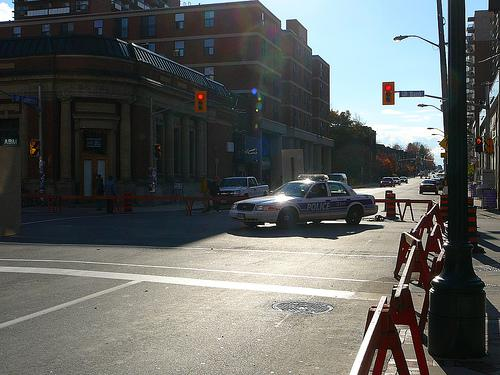Question: why is the police car in the middle of the street?
Choices:
A. Block traffic.
B. Traffic stop.
C. Accident.
D. Arrest.
Answer with the letter. Answer: A Question: who drives the car in the middle of the street?
Choices:
A. Ambulance.
B. Police.
C. Fire fighters.
D. Bad drivers.
Answer with the letter. Answer: B Question: what is on the police car roof?
Choices:
A. Paint.
B. Lights.
C. Sirens.
D. Bike rack.
Answer with the letter. Answer: B 